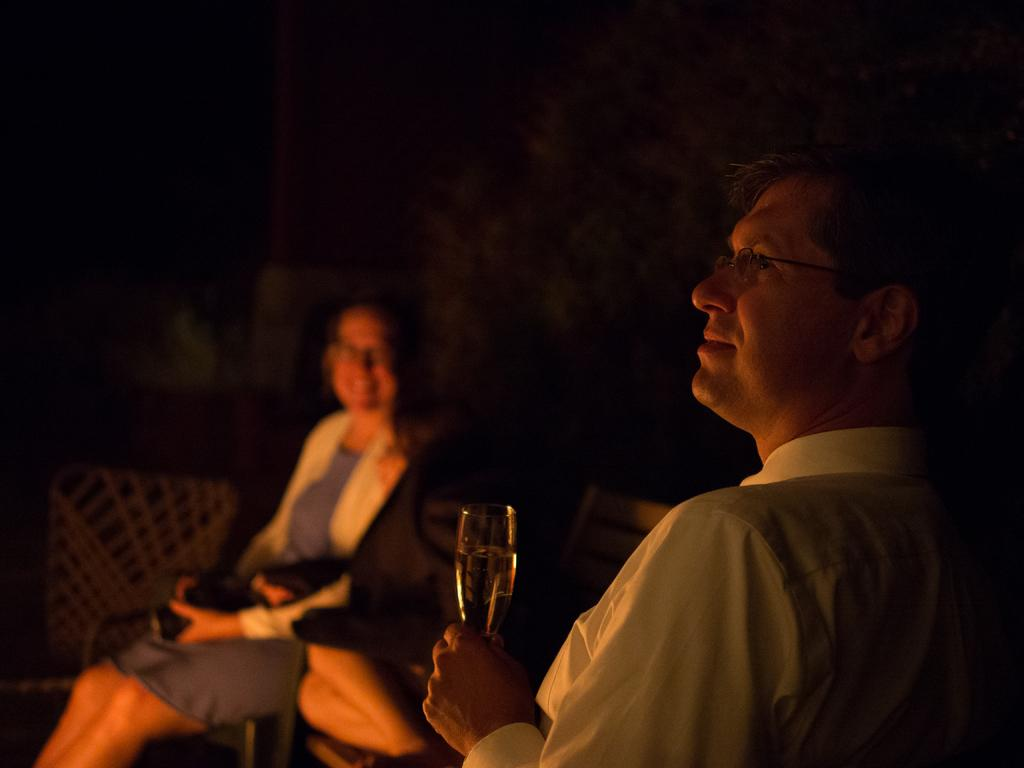What are the two people in the image doing? There is a man and a woman sitting in the image. What is the person on the right side holding? The person on the right side is holding a glass in his hand. What is the person on the right side wearing? The person on the right side is wearing a white shirt and spectacles. What type of cars can be seen in the hospital in the image? There is no mention of cars or a hospital in the image; it features a man and a woman sitting together. 